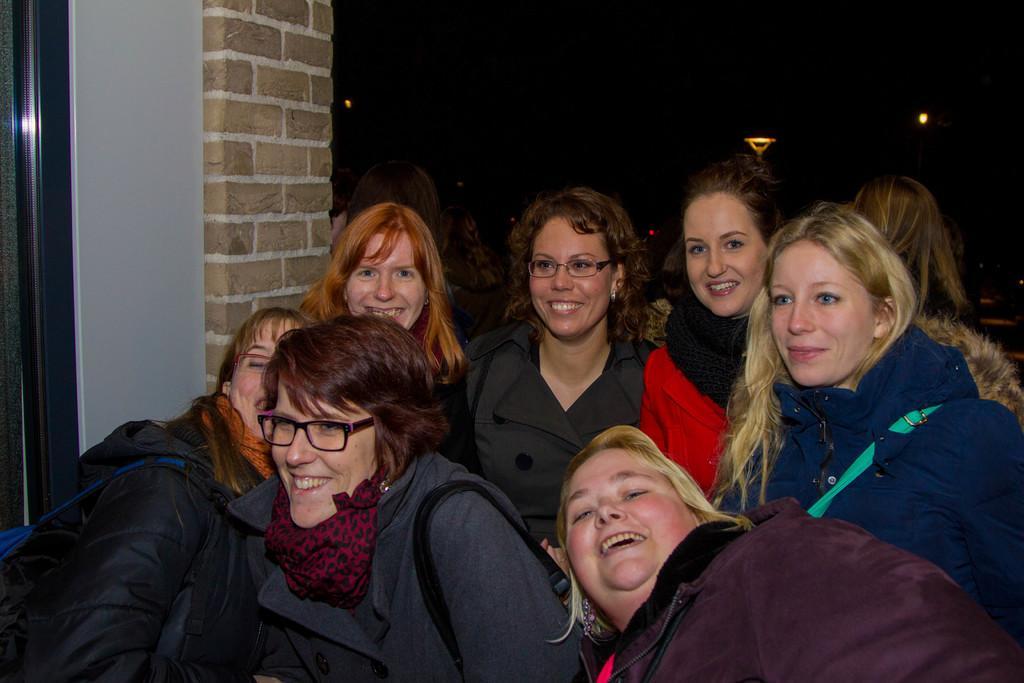Describe this image in one or two sentences. In this image there are a group of persons are standing at bottom of this image as we can see there is a wall at left side of this image and there is a light at top of this image. 